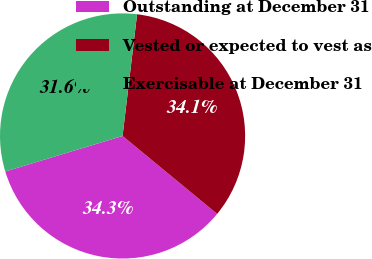Convert chart. <chart><loc_0><loc_0><loc_500><loc_500><pie_chart><fcel>Outstanding at December 31<fcel>Vested or expected to vest as<fcel>Exercisable at December 31<nl><fcel>34.35%<fcel>34.08%<fcel>31.57%<nl></chart> 